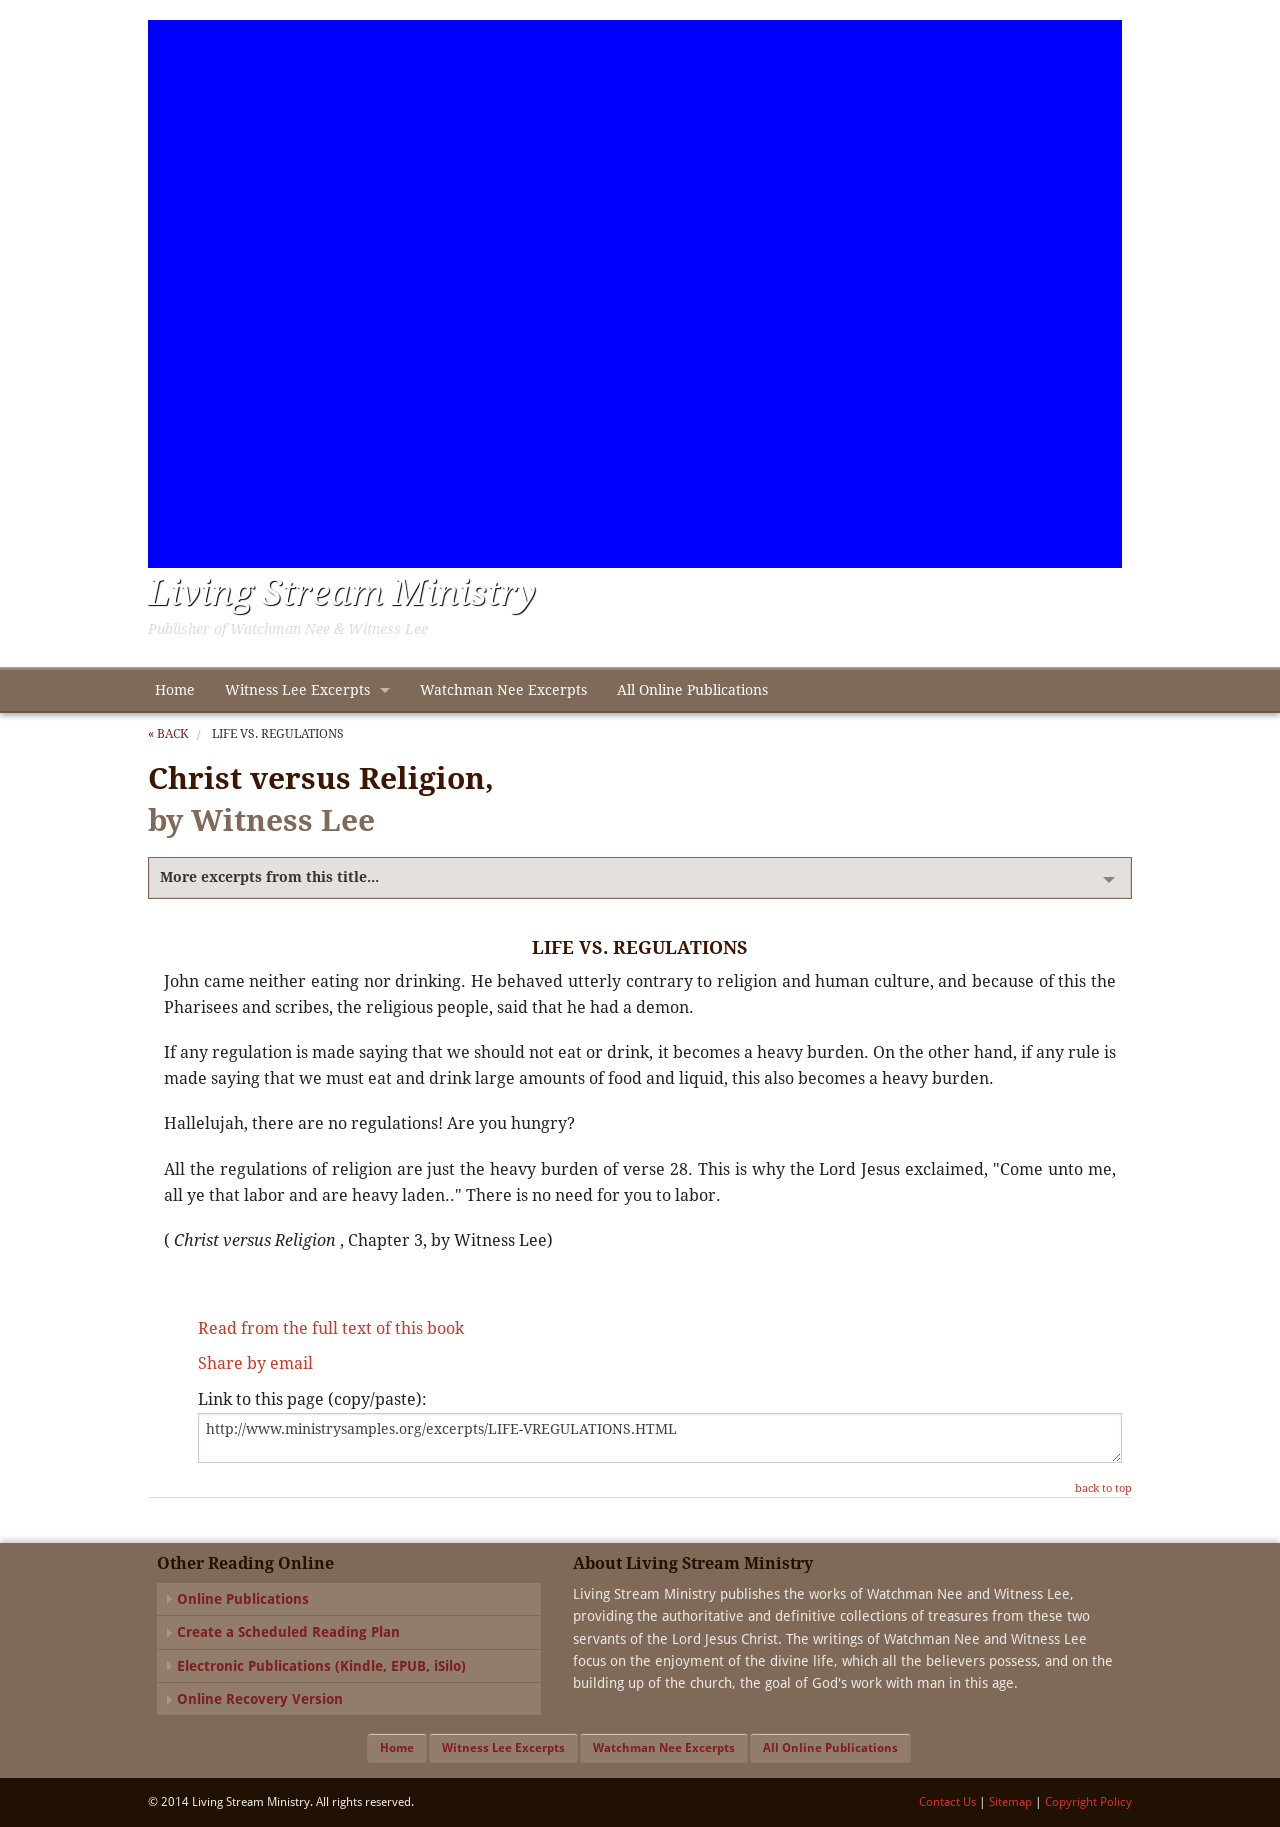How can I start building this website with HTML from the ground up? To start building a website with HTML from the ground up, begin by creating the basic structure. Start with the 'DOCTYPE' declaration. Use '<html>' to wrap the entire content. Inside, you'll divide your content into '<head>' (for metadata, styles, and scripts) and '<body>' (for visible page content). Here’s a simple template:

<!DOCTYPE html>
<html>
<head>
    <title>Your Website Title</title>
</head>
<body>
    <h1>Hello, welcome to my website!</h1>
    <p>This is a paragraph of text on my website.</p>
</body>
</html>

This code sets up a basic webpage with a title, header, and a paragraph. From here, you can expand by adding more HTML elements like images, links, lists, and use CSS for styling and JavaScript for functionality. 